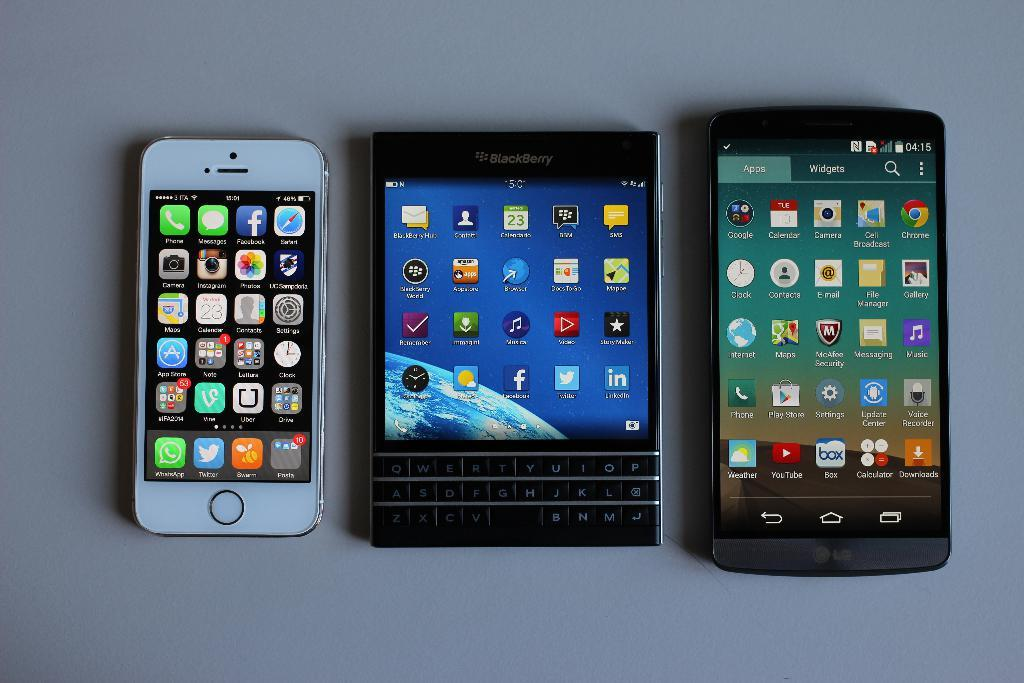<image>
Summarize the visual content of the image. A trio of three phones are laid down on a surface, one is a LG and other a BLACKBERRY. 